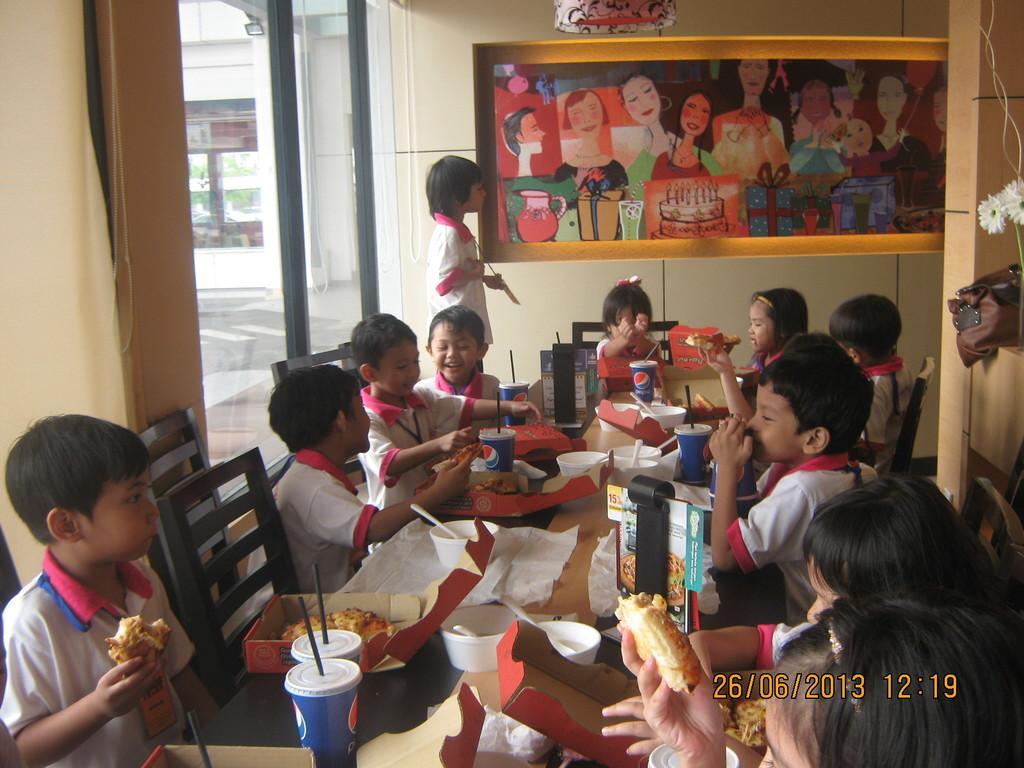How would you summarize this image in a sentence or two? In the picture we can see a house inside it we can see a table and some chairs near it and some children sitting and having their meals which are on the table, and on the table we can see some meals, glasses and straws in it and we can also see some tissues and behind them we can see a wall with a photo frame and painting on it and beside it we can see a glass wall. 